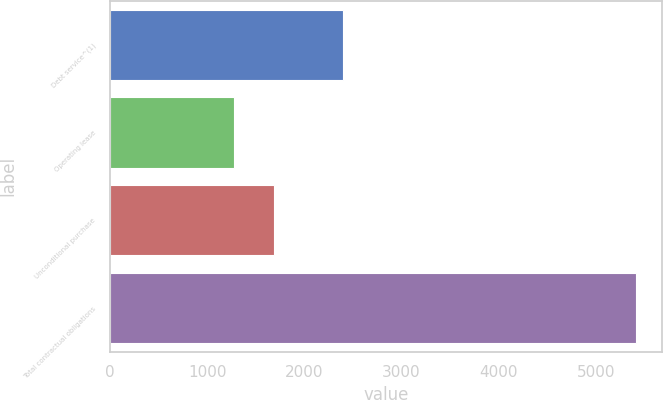Convert chart to OTSL. <chart><loc_0><loc_0><loc_500><loc_500><bar_chart><fcel>Debt service^(1)<fcel>Operating lease<fcel>Unconditional purchase<fcel>Total contractual obligations<nl><fcel>2402.7<fcel>1274.2<fcel>1688.31<fcel>5415.3<nl></chart> 